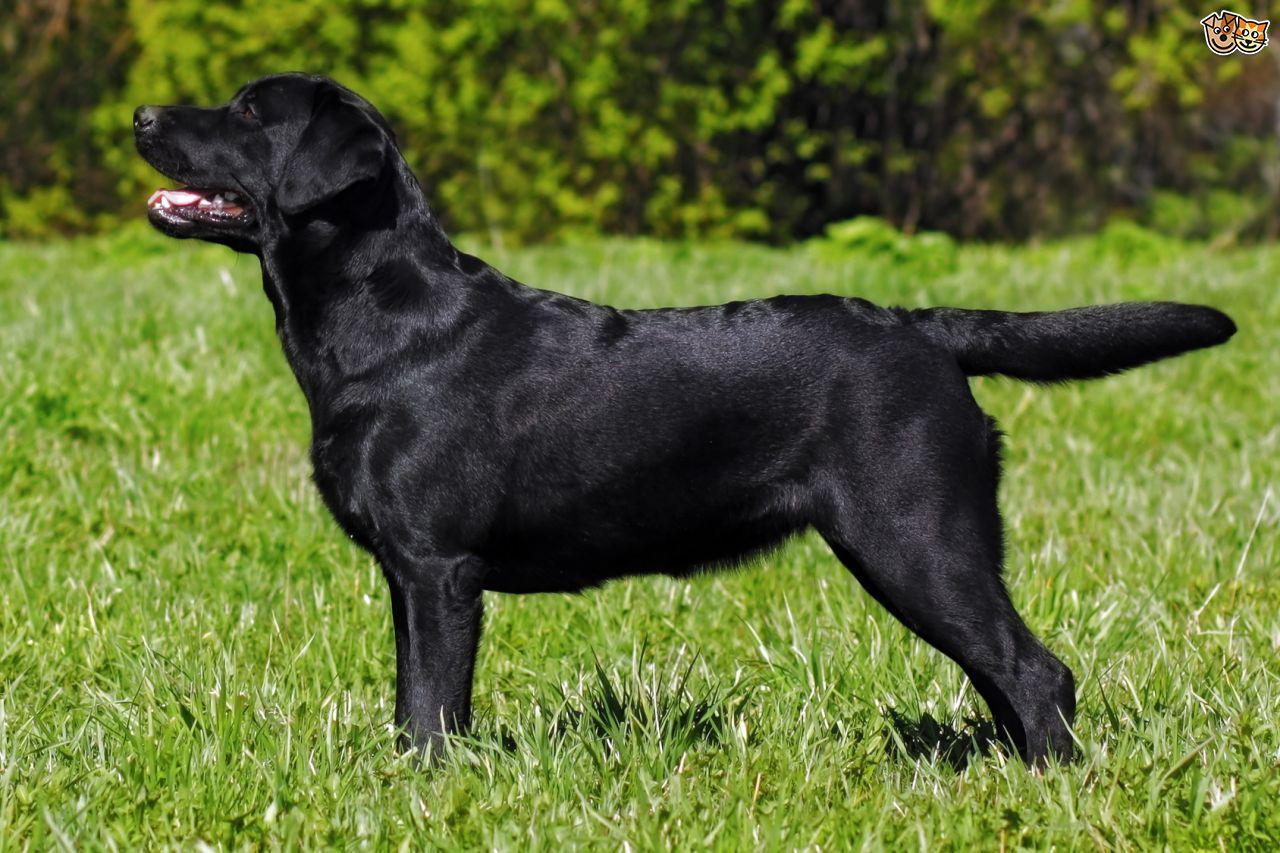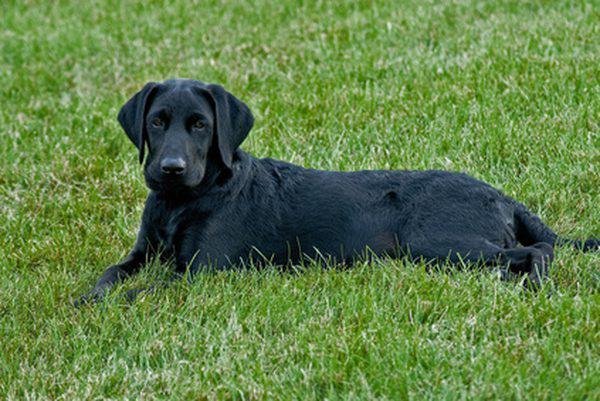The first image is the image on the left, the second image is the image on the right. For the images shown, is this caption "A dog is standing and facing left." true? Answer yes or no. Yes. 